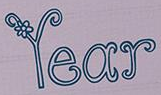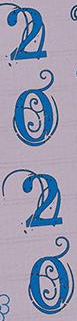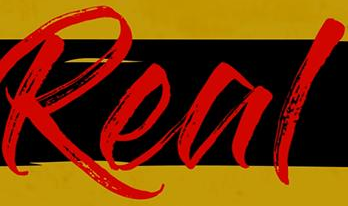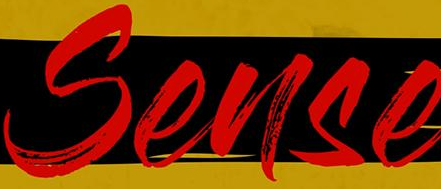What words can you see in these images in sequence, separated by a semicolon? Year; 2020; Real; Sense 